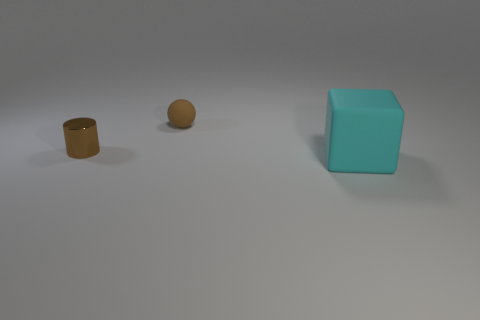Add 2 small brown rubber objects. How many objects exist? 5 Subtract all blocks. How many objects are left? 2 Subtract 0 red cylinders. How many objects are left? 3 Subtract all yellow objects. Subtract all small metallic cylinders. How many objects are left? 2 Add 2 cyan things. How many cyan things are left? 3 Add 2 brown metal cylinders. How many brown metal cylinders exist? 3 